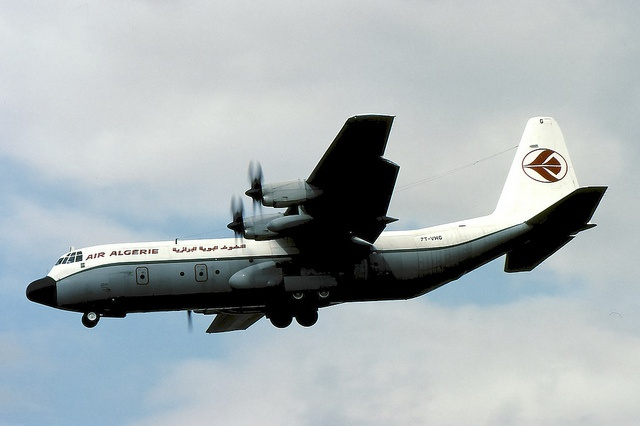Describe the objects in this image and their specific colors. I can see a airplane in lightgray, black, ivory, gray, and darkgray tones in this image. 